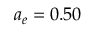Convert formula to latex. <formula><loc_0><loc_0><loc_500><loc_500>a _ { e } = 0 . 5 0</formula> 